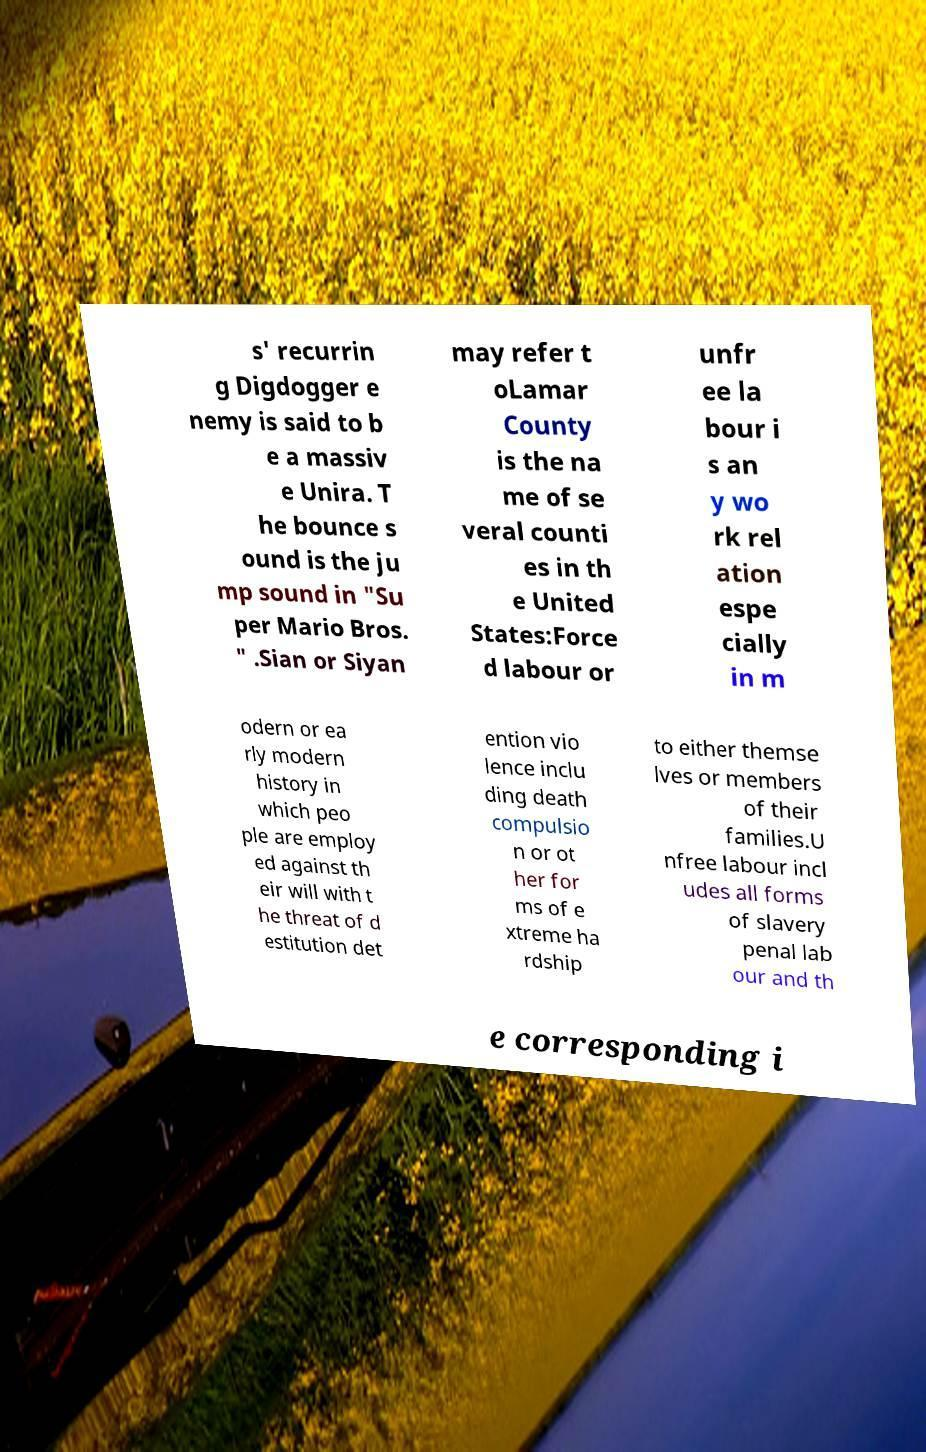Please identify and transcribe the text found in this image. s' recurrin g Digdogger e nemy is said to b e a massiv e Unira. T he bounce s ound is the ju mp sound in "Su per Mario Bros. " .Sian or Siyan may refer t oLamar County is the na me of se veral counti es in th e United States:Force d labour or unfr ee la bour i s an y wo rk rel ation espe cially in m odern or ea rly modern history in which peo ple are employ ed against th eir will with t he threat of d estitution det ention vio lence inclu ding death compulsio n or ot her for ms of e xtreme ha rdship to either themse lves or members of their families.U nfree labour incl udes all forms of slavery penal lab our and th e corresponding i 